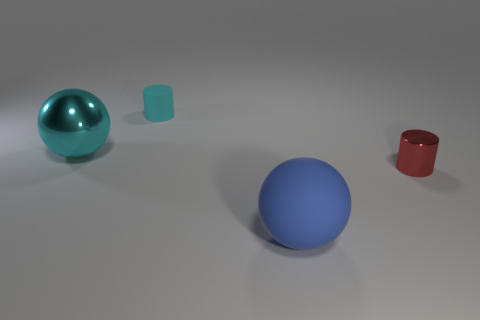Is the number of blue matte things right of the red metallic thing greater than the number of green rubber things?
Make the answer very short. No. How many other objects are there of the same size as the cyan metallic thing?
Keep it short and to the point. 1. How many objects are in front of the small cyan object and behind the red shiny thing?
Provide a succinct answer. 1. Are the sphere to the left of the big blue thing and the tiny cyan object made of the same material?
Offer a terse response. No. The metal object in front of the metal object that is behind the cylinder in front of the large metallic object is what shape?
Offer a terse response. Cylinder. Are there the same number of rubber spheres to the right of the red metallic thing and blue rubber spheres that are behind the tiny rubber cylinder?
Provide a succinct answer. Yes. What is the color of the rubber cylinder that is the same size as the red thing?
Offer a terse response. Cyan. What number of small things are either blue rubber spheres or cylinders?
Provide a succinct answer. 2. What is the material of the thing that is both right of the rubber cylinder and left of the red cylinder?
Provide a succinct answer. Rubber. There is a rubber thing that is behind the small metallic cylinder; is its shape the same as the big object that is left of the large blue rubber sphere?
Offer a very short reply. No. 